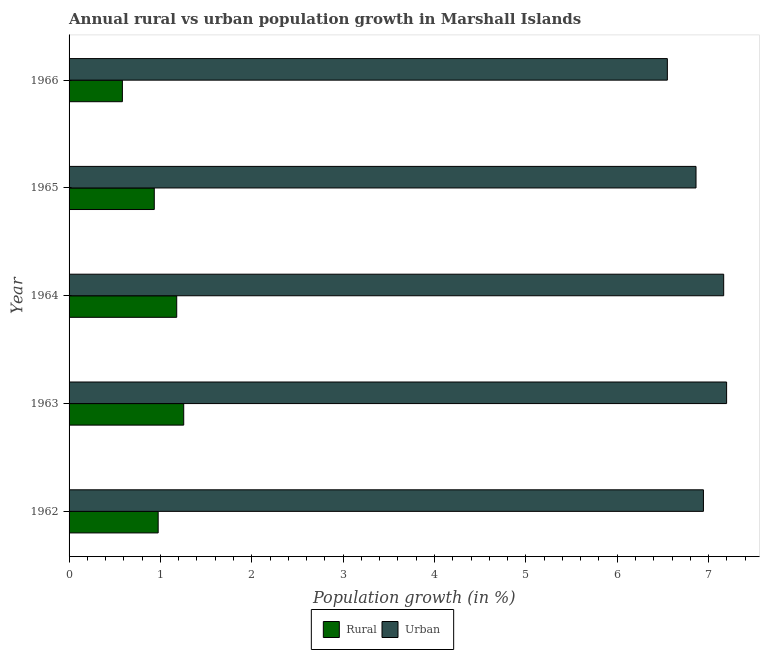How many different coloured bars are there?
Provide a succinct answer. 2. How many groups of bars are there?
Provide a succinct answer. 5. How many bars are there on the 1st tick from the bottom?
Make the answer very short. 2. What is the label of the 1st group of bars from the top?
Provide a succinct answer. 1966. What is the rural population growth in 1965?
Your response must be concise. 0.93. Across all years, what is the maximum rural population growth?
Give a very brief answer. 1.25. Across all years, what is the minimum rural population growth?
Offer a terse response. 0.58. In which year was the rural population growth maximum?
Provide a short and direct response. 1963. In which year was the urban population growth minimum?
Give a very brief answer. 1966. What is the total rural population growth in the graph?
Offer a very short reply. 4.92. What is the difference between the rural population growth in 1962 and that in 1963?
Your response must be concise. -0.28. What is the difference between the rural population growth in 1963 and the urban population growth in 1962?
Your answer should be compact. -5.69. What is the average urban population growth per year?
Your answer should be very brief. 6.94. In the year 1963, what is the difference between the urban population growth and rural population growth?
Ensure brevity in your answer.  5.94. What is the ratio of the rural population growth in 1963 to that in 1964?
Provide a short and direct response. 1.06. Is the rural population growth in 1963 less than that in 1966?
Make the answer very short. No. What is the difference between the highest and the second highest urban population growth?
Offer a very short reply. 0.03. What is the difference between the highest and the lowest urban population growth?
Ensure brevity in your answer.  0.65. What does the 1st bar from the top in 1964 represents?
Ensure brevity in your answer.  Urban . What does the 1st bar from the bottom in 1964 represents?
Your response must be concise. Rural. How many bars are there?
Give a very brief answer. 10. Does the graph contain any zero values?
Offer a very short reply. No. Does the graph contain grids?
Keep it short and to the point. No. How many legend labels are there?
Provide a succinct answer. 2. What is the title of the graph?
Provide a succinct answer. Annual rural vs urban population growth in Marshall Islands. Does "All education staff compensation" appear as one of the legend labels in the graph?
Give a very brief answer. No. What is the label or title of the X-axis?
Give a very brief answer. Population growth (in %). What is the Population growth (in %) in Rural in 1962?
Give a very brief answer. 0.98. What is the Population growth (in %) of Urban  in 1962?
Give a very brief answer. 6.94. What is the Population growth (in %) in Rural in 1963?
Keep it short and to the point. 1.25. What is the Population growth (in %) of Urban  in 1963?
Your answer should be compact. 7.2. What is the Population growth (in %) in Rural in 1964?
Make the answer very short. 1.18. What is the Population growth (in %) of Urban  in 1964?
Provide a short and direct response. 7.17. What is the Population growth (in %) of Rural in 1965?
Provide a short and direct response. 0.93. What is the Population growth (in %) in Urban  in 1965?
Your answer should be very brief. 6.86. What is the Population growth (in %) in Rural in 1966?
Your response must be concise. 0.58. What is the Population growth (in %) of Urban  in 1966?
Your answer should be compact. 6.55. Across all years, what is the maximum Population growth (in %) of Rural?
Offer a terse response. 1.25. Across all years, what is the maximum Population growth (in %) of Urban ?
Keep it short and to the point. 7.2. Across all years, what is the minimum Population growth (in %) in Rural?
Your answer should be compact. 0.58. Across all years, what is the minimum Population growth (in %) in Urban ?
Your answer should be very brief. 6.55. What is the total Population growth (in %) of Rural in the graph?
Make the answer very short. 4.92. What is the total Population growth (in %) of Urban  in the graph?
Offer a very short reply. 34.72. What is the difference between the Population growth (in %) of Rural in 1962 and that in 1963?
Provide a short and direct response. -0.28. What is the difference between the Population growth (in %) of Urban  in 1962 and that in 1963?
Offer a terse response. -0.25. What is the difference between the Population growth (in %) in Rural in 1962 and that in 1964?
Offer a terse response. -0.2. What is the difference between the Population growth (in %) of Urban  in 1962 and that in 1964?
Offer a very short reply. -0.22. What is the difference between the Population growth (in %) of Rural in 1962 and that in 1965?
Keep it short and to the point. 0.04. What is the difference between the Population growth (in %) of Urban  in 1962 and that in 1965?
Provide a succinct answer. 0.08. What is the difference between the Population growth (in %) in Rural in 1962 and that in 1966?
Your response must be concise. 0.39. What is the difference between the Population growth (in %) in Urban  in 1962 and that in 1966?
Offer a very short reply. 0.39. What is the difference between the Population growth (in %) in Rural in 1963 and that in 1964?
Your answer should be very brief. 0.08. What is the difference between the Population growth (in %) of Urban  in 1963 and that in 1964?
Provide a short and direct response. 0.03. What is the difference between the Population growth (in %) in Rural in 1963 and that in 1965?
Provide a short and direct response. 0.32. What is the difference between the Population growth (in %) of Urban  in 1963 and that in 1965?
Ensure brevity in your answer.  0.33. What is the difference between the Population growth (in %) of Rural in 1963 and that in 1966?
Keep it short and to the point. 0.67. What is the difference between the Population growth (in %) in Urban  in 1963 and that in 1966?
Your response must be concise. 0.65. What is the difference between the Population growth (in %) in Rural in 1964 and that in 1965?
Keep it short and to the point. 0.25. What is the difference between the Population growth (in %) in Urban  in 1964 and that in 1965?
Provide a succinct answer. 0.3. What is the difference between the Population growth (in %) of Rural in 1964 and that in 1966?
Provide a succinct answer. 0.59. What is the difference between the Population growth (in %) in Urban  in 1964 and that in 1966?
Make the answer very short. 0.62. What is the difference between the Population growth (in %) in Rural in 1965 and that in 1966?
Ensure brevity in your answer.  0.35. What is the difference between the Population growth (in %) in Urban  in 1965 and that in 1966?
Keep it short and to the point. 0.31. What is the difference between the Population growth (in %) in Rural in 1962 and the Population growth (in %) in Urban  in 1963?
Make the answer very short. -6.22. What is the difference between the Population growth (in %) in Rural in 1962 and the Population growth (in %) in Urban  in 1964?
Ensure brevity in your answer.  -6.19. What is the difference between the Population growth (in %) in Rural in 1962 and the Population growth (in %) in Urban  in 1965?
Give a very brief answer. -5.89. What is the difference between the Population growth (in %) in Rural in 1962 and the Population growth (in %) in Urban  in 1966?
Your answer should be very brief. -5.57. What is the difference between the Population growth (in %) of Rural in 1963 and the Population growth (in %) of Urban  in 1964?
Keep it short and to the point. -5.91. What is the difference between the Population growth (in %) of Rural in 1963 and the Population growth (in %) of Urban  in 1965?
Offer a very short reply. -5.61. What is the difference between the Population growth (in %) in Rural in 1963 and the Population growth (in %) in Urban  in 1966?
Keep it short and to the point. -5.29. What is the difference between the Population growth (in %) in Rural in 1964 and the Population growth (in %) in Urban  in 1965?
Keep it short and to the point. -5.68. What is the difference between the Population growth (in %) in Rural in 1964 and the Population growth (in %) in Urban  in 1966?
Your answer should be compact. -5.37. What is the difference between the Population growth (in %) in Rural in 1965 and the Population growth (in %) in Urban  in 1966?
Keep it short and to the point. -5.62. What is the average Population growth (in %) in Rural per year?
Make the answer very short. 0.98. What is the average Population growth (in %) in Urban  per year?
Give a very brief answer. 6.94. In the year 1962, what is the difference between the Population growth (in %) in Rural and Population growth (in %) in Urban ?
Provide a short and direct response. -5.97. In the year 1963, what is the difference between the Population growth (in %) in Rural and Population growth (in %) in Urban ?
Your response must be concise. -5.94. In the year 1964, what is the difference between the Population growth (in %) in Rural and Population growth (in %) in Urban ?
Offer a very short reply. -5.99. In the year 1965, what is the difference between the Population growth (in %) of Rural and Population growth (in %) of Urban ?
Your answer should be very brief. -5.93. In the year 1966, what is the difference between the Population growth (in %) in Rural and Population growth (in %) in Urban ?
Give a very brief answer. -5.97. What is the ratio of the Population growth (in %) of Rural in 1962 to that in 1963?
Give a very brief answer. 0.78. What is the ratio of the Population growth (in %) in Urban  in 1962 to that in 1963?
Offer a terse response. 0.96. What is the ratio of the Population growth (in %) of Rural in 1962 to that in 1964?
Provide a short and direct response. 0.83. What is the ratio of the Population growth (in %) in Urban  in 1962 to that in 1964?
Your answer should be very brief. 0.97. What is the ratio of the Population growth (in %) of Rural in 1962 to that in 1965?
Provide a succinct answer. 1.05. What is the ratio of the Population growth (in %) of Urban  in 1962 to that in 1965?
Offer a terse response. 1.01. What is the ratio of the Population growth (in %) in Rural in 1962 to that in 1966?
Provide a succinct answer. 1.67. What is the ratio of the Population growth (in %) in Urban  in 1962 to that in 1966?
Keep it short and to the point. 1.06. What is the ratio of the Population growth (in %) of Rural in 1963 to that in 1964?
Provide a short and direct response. 1.07. What is the ratio of the Population growth (in %) of Rural in 1963 to that in 1965?
Make the answer very short. 1.35. What is the ratio of the Population growth (in %) in Urban  in 1963 to that in 1965?
Your response must be concise. 1.05. What is the ratio of the Population growth (in %) in Rural in 1963 to that in 1966?
Ensure brevity in your answer.  2.15. What is the ratio of the Population growth (in %) of Urban  in 1963 to that in 1966?
Ensure brevity in your answer.  1.1. What is the ratio of the Population growth (in %) in Rural in 1964 to that in 1965?
Make the answer very short. 1.26. What is the ratio of the Population growth (in %) in Urban  in 1964 to that in 1965?
Your answer should be compact. 1.04. What is the ratio of the Population growth (in %) of Rural in 1964 to that in 1966?
Keep it short and to the point. 2.02. What is the ratio of the Population growth (in %) in Urban  in 1964 to that in 1966?
Offer a terse response. 1.09. What is the ratio of the Population growth (in %) of Rural in 1965 to that in 1966?
Provide a succinct answer. 1.6. What is the ratio of the Population growth (in %) in Urban  in 1965 to that in 1966?
Offer a terse response. 1.05. What is the difference between the highest and the second highest Population growth (in %) of Rural?
Provide a short and direct response. 0.08. What is the difference between the highest and the second highest Population growth (in %) of Urban ?
Your answer should be very brief. 0.03. What is the difference between the highest and the lowest Population growth (in %) of Rural?
Ensure brevity in your answer.  0.67. What is the difference between the highest and the lowest Population growth (in %) in Urban ?
Provide a succinct answer. 0.65. 